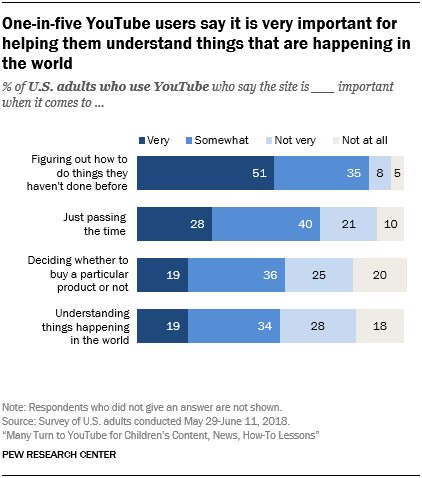Highlight a few significant elements in this photo. The ratio of the two smallest gray bars is approximately 0.215277778, which can be expressed as a decimal. The color of the rightmost bars is gray. 